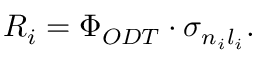Convert formula to latex. <formula><loc_0><loc_0><loc_500><loc_500>R _ { i } = \Phi _ { O D T } \cdot \sigma _ { n _ { i } l _ { i } } .</formula> 